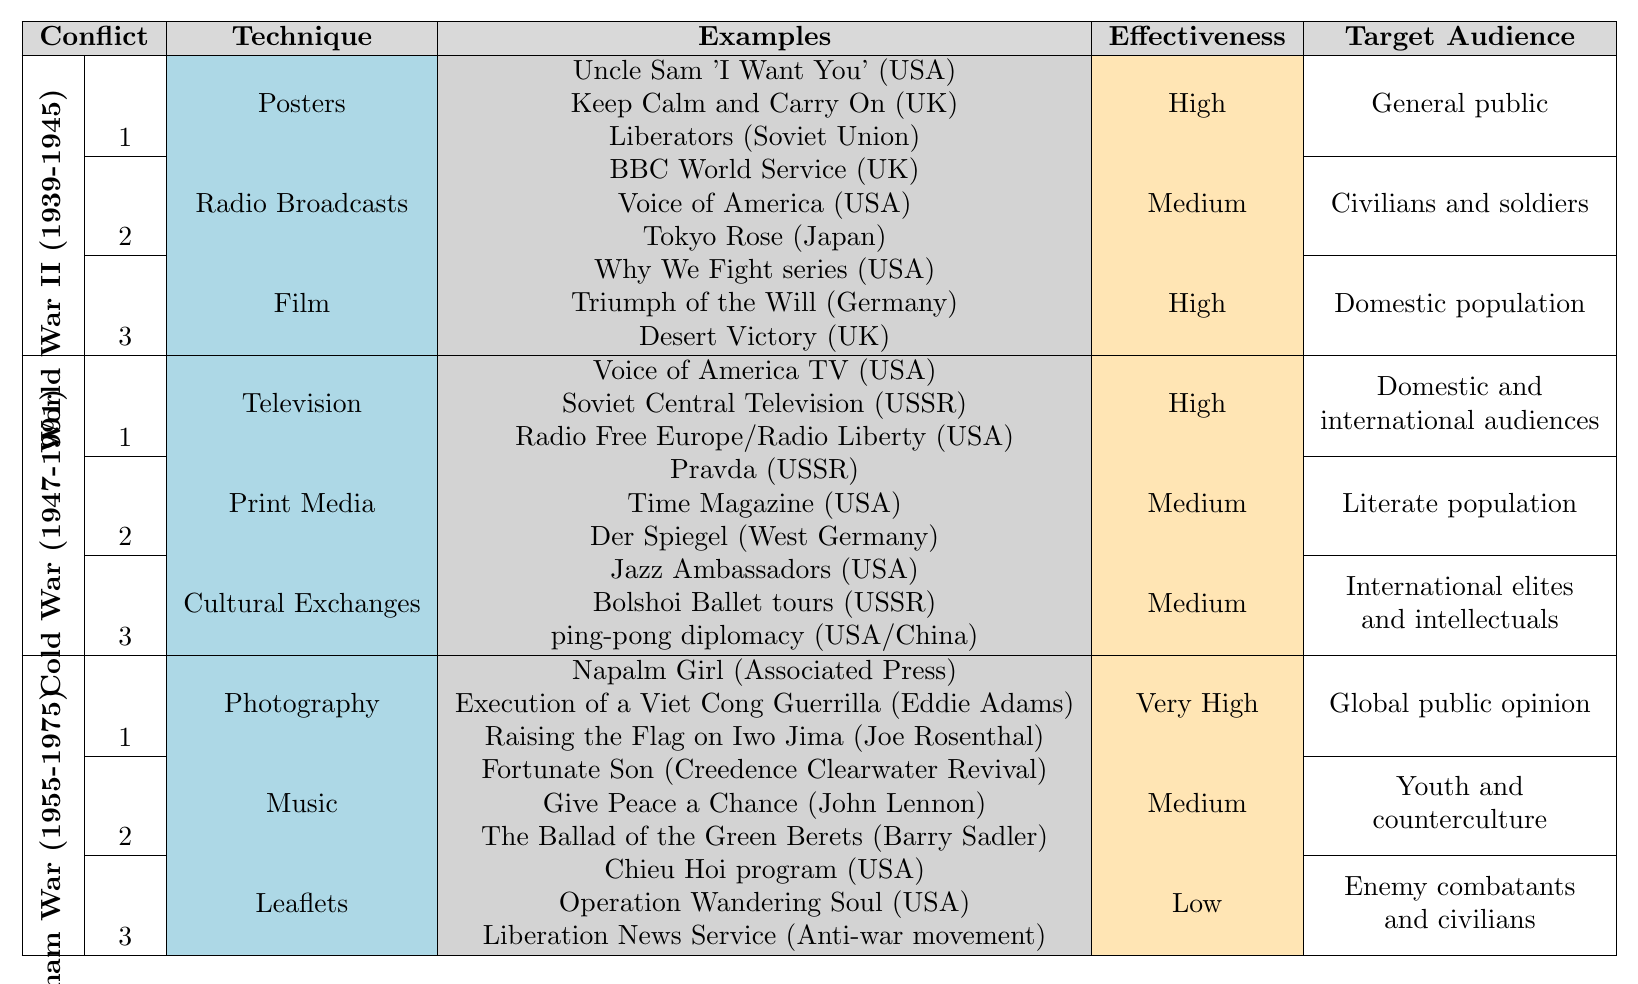What are the two primary techniques used in World War II with high effectiveness? According to the table, the techniques listed under World War II with high effectiveness are 'Posters' and 'Film'.
Answer: Posters and Film Which conflict had the highest effectiveness for photography as a propaganda technique? The table indicates that the Vietnam War had the highest effectiveness for 'Photography', rated as 'Very High'.
Answer: Vietnam War How many propaganda techniques were used during the Cold War? The Cold War had three listed techniques: Television, Print Media, and Cultural Exchanges.
Answer: Three Which technique had the lowest effectiveness in the Vietnam War? The table shows that 'Leaflets' were rated as having 'Low' effectiveness.
Answer: Leaflets What was the target audience for 'Cultural Exchanges' during the Cold War? The target audience for 'Cultural Exchanges' during the Cold War was determined to be 'International elites and intellectuals'.
Answer: International elites and intellectuals Which conflict used 'Music' as a propaganda technique, and what was its effectiveness? The table indicates that 'Music' was used in the Vietnam War and its effectiveness was rated as 'Medium'.
Answer: Vietnam War, Medium Is it true that the USA employed 'Radio Broadcasts' as a technique in World War II? The table confirms that 'Radio Broadcasts' were indeed a technique used by the USA during World War II.
Answer: Yes What is the effectiveness of 'Television' as a propaganda technique in the Cold War, and who was the target audience? The effectiveness of 'Television' in the Cold War was rated 'High', and it targeted both domestic and international audiences.
Answer: High, Domestic and international audiences How does the effectiveness of 'Music' compare to 'Leaflets' in the Vietnam War? The table shows 'Music' had a 'Medium' effectiveness, whereas 'Leaflets' had 'Low' effectiveness, indicating that music was more effective than leaflets.
Answer: Music is more effective than Leaflets Determine the change in target audience between the 'Posters' technique in World War II and the 'Print Media' technique in the Cold War. The target audience for 'Posters' in World War II was the 'General public', while 'Print Media' in the Cold War targeted the 'Literate population', indicating a shift from a broader audience to a more educated demographic.
Answer: Shift from General public to Literate population 